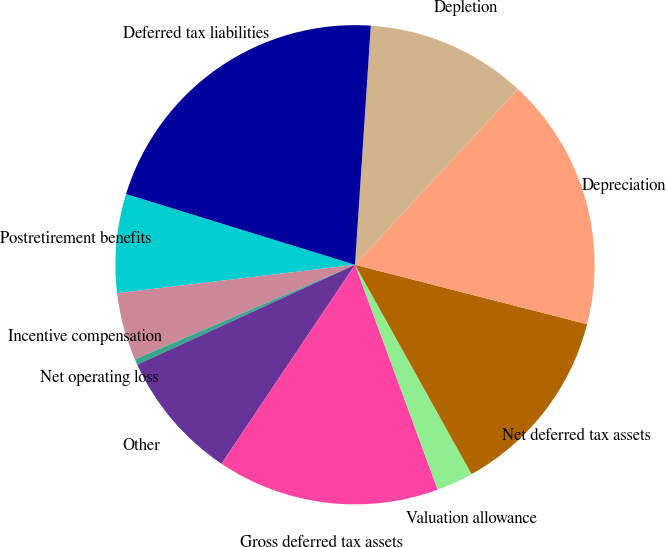Convert chart. <chart><loc_0><loc_0><loc_500><loc_500><pie_chart><fcel>Postretirement benefits<fcel>Incentive compensation<fcel>Net operating loss<fcel>Other<fcel>Gross deferred tax assets<fcel>Valuation allowance<fcel>Net deferred tax assets<fcel>Depreciation<fcel>Depletion<fcel>Deferred tax liabilities<nl><fcel>6.66%<fcel>4.57%<fcel>0.39%<fcel>8.75%<fcel>15.01%<fcel>2.48%<fcel>12.92%<fcel>17.1%<fcel>10.84%<fcel>21.28%<nl></chart> 